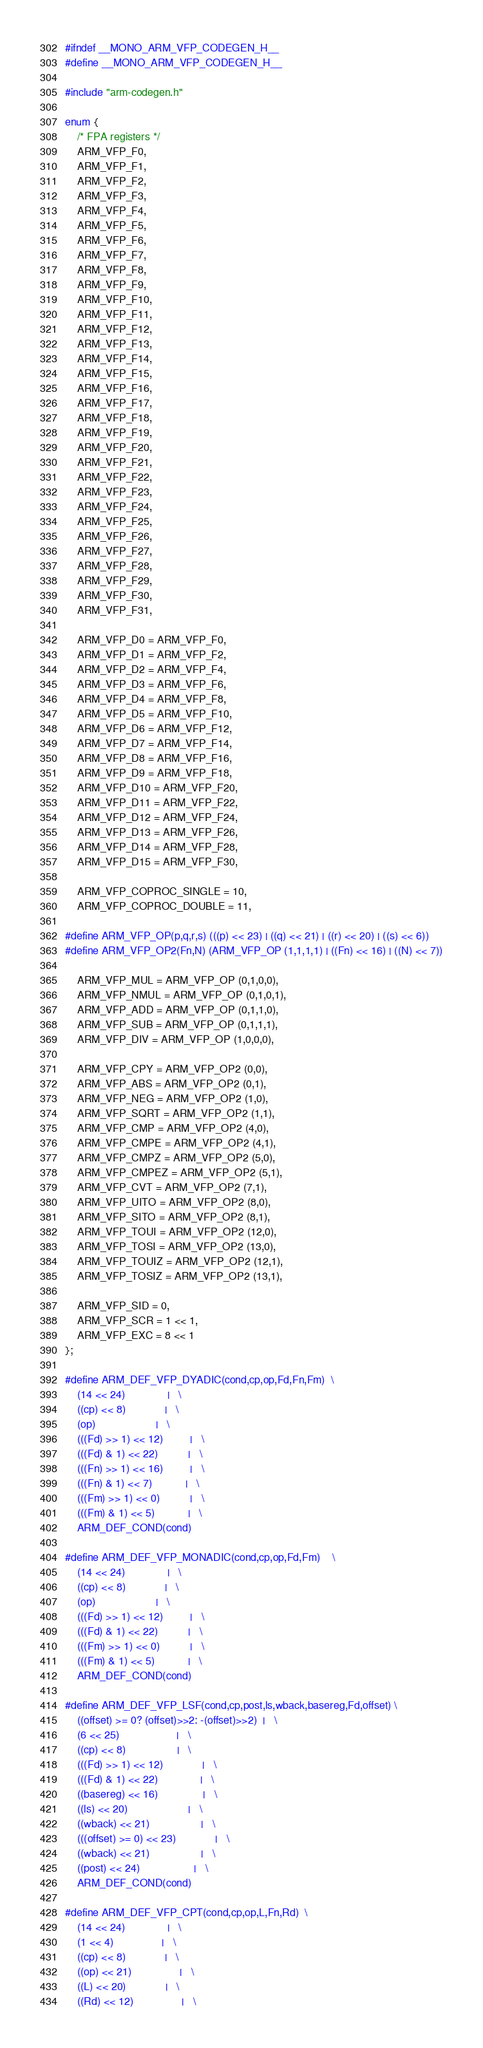Convert code to text. <code><loc_0><loc_0><loc_500><loc_500><_C_>#ifndef __MONO_ARM_VFP_CODEGEN_H__
#define __MONO_ARM_VFP_CODEGEN_H__

#include "arm-codegen.h"

enum {
	/* FPA registers */
	ARM_VFP_F0,
	ARM_VFP_F1,
	ARM_VFP_F2,
	ARM_VFP_F3,
	ARM_VFP_F4,
	ARM_VFP_F5,
	ARM_VFP_F6,
	ARM_VFP_F7,
	ARM_VFP_F8,
	ARM_VFP_F9,
	ARM_VFP_F10,
	ARM_VFP_F11,
	ARM_VFP_F12,
	ARM_VFP_F13,
	ARM_VFP_F14,
	ARM_VFP_F15,
	ARM_VFP_F16,
	ARM_VFP_F17,
	ARM_VFP_F18,
	ARM_VFP_F19,
	ARM_VFP_F20,
	ARM_VFP_F21,
	ARM_VFP_F22,
	ARM_VFP_F23,
	ARM_VFP_F24,
	ARM_VFP_F25,
	ARM_VFP_F26,
	ARM_VFP_F27,
	ARM_VFP_F28,
	ARM_VFP_F29,
	ARM_VFP_F30,
	ARM_VFP_F31,

	ARM_VFP_D0 = ARM_VFP_F0,
	ARM_VFP_D1 = ARM_VFP_F2,
	ARM_VFP_D2 = ARM_VFP_F4,
	ARM_VFP_D3 = ARM_VFP_F6,
	ARM_VFP_D4 = ARM_VFP_F8,
	ARM_VFP_D5 = ARM_VFP_F10,
	ARM_VFP_D6 = ARM_VFP_F12,
	ARM_VFP_D7 = ARM_VFP_F14,
	ARM_VFP_D8 = ARM_VFP_F16,
	ARM_VFP_D9 = ARM_VFP_F18,
	ARM_VFP_D10 = ARM_VFP_F20,
	ARM_VFP_D11 = ARM_VFP_F22,
	ARM_VFP_D12 = ARM_VFP_F24,
	ARM_VFP_D13 = ARM_VFP_F26,
	ARM_VFP_D14 = ARM_VFP_F28,
	ARM_VFP_D15 = ARM_VFP_F30,

	ARM_VFP_COPROC_SINGLE = 10,
	ARM_VFP_COPROC_DOUBLE = 11,

#define ARM_VFP_OP(p,q,r,s) (((p) << 23) | ((q) << 21) | ((r) << 20) | ((s) << 6))
#define ARM_VFP_OP2(Fn,N) (ARM_VFP_OP (1,1,1,1) | ((Fn) << 16) | ((N) << 7))

	ARM_VFP_MUL = ARM_VFP_OP (0,1,0,0),
	ARM_VFP_NMUL = ARM_VFP_OP (0,1,0,1),
	ARM_VFP_ADD = ARM_VFP_OP (0,1,1,0),
	ARM_VFP_SUB = ARM_VFP_OP (0,1,1,1),
	ARM_VFP_DIV = ARM_VFP_OP (1,0,0,0),

	ARM_VFP_CPY = ARM_VFP_OP2 (0,0),
	ARM_VFP_ABS = ARM_VFP_OP2 (0,1),
	ARM_VFP_NEG = ARM_VFP_OP2 (1,0),
	ARM_VFP_SQRT = ARM_VFP_OP2 (1,1),
	ARM_VFP_CMP = ARM_VFP_OP2 (4,0),
	ARM_VFP_CMPE = ARM_VFP_OP2 (4,1),
	ARM_VFP_CMPZ = ARM_VFP_OP2 (5,0),
	ARM_VFP_CMPEZ = ARM_VFP_OP2 (5,1),
	ARM_VFP_CVT = ARM_VFP_OP2 (7,1),
	ARM_VFP_UITO = ARM_VFP_OP2 (8,0),
	ARM_VFP_SITO = ARM_VFP_OP2 (8,1),
	ARM_VFP_TOUI = ARM_VFP_OP2 (12,0),
	ARM_VFP_TOSI = ARM_VFP_OP2 (13,0),
	ARM_VFP_TOUIZ = ARM_VFP_OP2 (12,1),
	ARM_VFP_TOSIZ = ARM_VFP_OP2 (13,1),

	ARM_VFP_SID = 0,
	ARM_VFP_SCR = 1 << 1,
	ARM_VFP_EXC = 8 << 1
};

#define ARM_DEF_VFP_DYADIC(cond,cp,op,Fd,Fn,Fm)	\
	(14 << 24)				|	\
	((cp) << 8)				|	\
	(op)					|	\
	(((Fd) >> 1) << 12)			|	\
	(((Fd) & 1) << 22)			|	\
	(((Fn) >> 1) << 16)			|	\
	(((Fn) & 1) << 7)			|	\
	(((Fm) >> 1) << 0)			|	\
	(((Fm) & 1) << 5)			|	\
	ARM_DEF_COND(cond)

#define ARM_DEF_VFP_MONADIC(cond,cp,op,Fd,Fm)	\
	(14 << 24)				|	\
	((cp) << 8)				|	\
	(op)					|	\
	(((Fd) >> 1) << 12)			|	\
	(((Fd) & 1) << 22)			|	\
	(((Fm) >> 1) << 0)			|	\
	(((Fm) & 1) << 5)			|	\
	ARM_DEF_COND(cond)

#define ARM_DEF_VFP_LSF(cond,cp,post,ls,wback,basereg,Fd,offset)	\
	((offset) >= 0? (offset)>>2: -(offset)>>2)	|	\
	(6 << 25)					|	\
	((cp) << 8)					|	\
	(((Fd) >> 1) << 12)				|	\
	(((Fd) & 1) << 22)				|	\
	((basereg) << 16)				|	\
	((ls) << 20)					|	\
	((wback) << 21)					|	\
	(((offset) >= 0) << 23)				|	\
	((wback) << 21)					|	\
	((post) << 24)					|	\
	ARM_DEF_COND(cond)

#define ARM_DEF_VFP_CPT(cond,cp,op,L,Fn,Rd)	\
	(14 << 24)				|	\
	(1 << 4)				|	\
	((cp) << 8)				|	\
	((op) << 21)				|	\
	((L) << 20)				|	\
	((Rd) << 12)				|	\</code> 